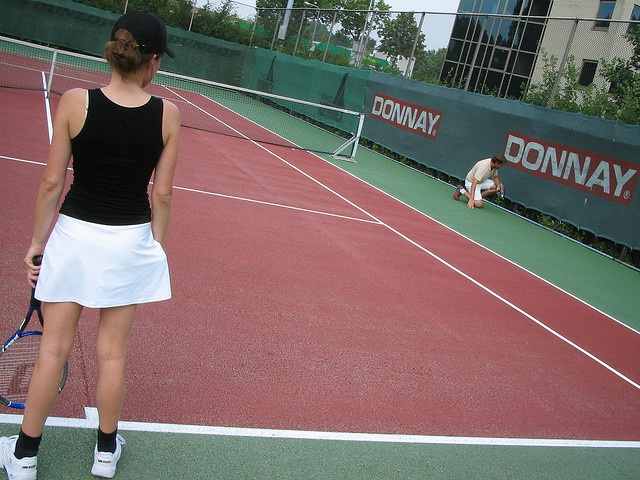Describe the objects in this image and their specific colors. I can see people in black, lavender, gray, and salmon tones, tennis racket in black, gray, and brown tones, people in black, lightgray, gray, and darkgray tones, and tennis racket in black, gray, and maroon tones in this image. 